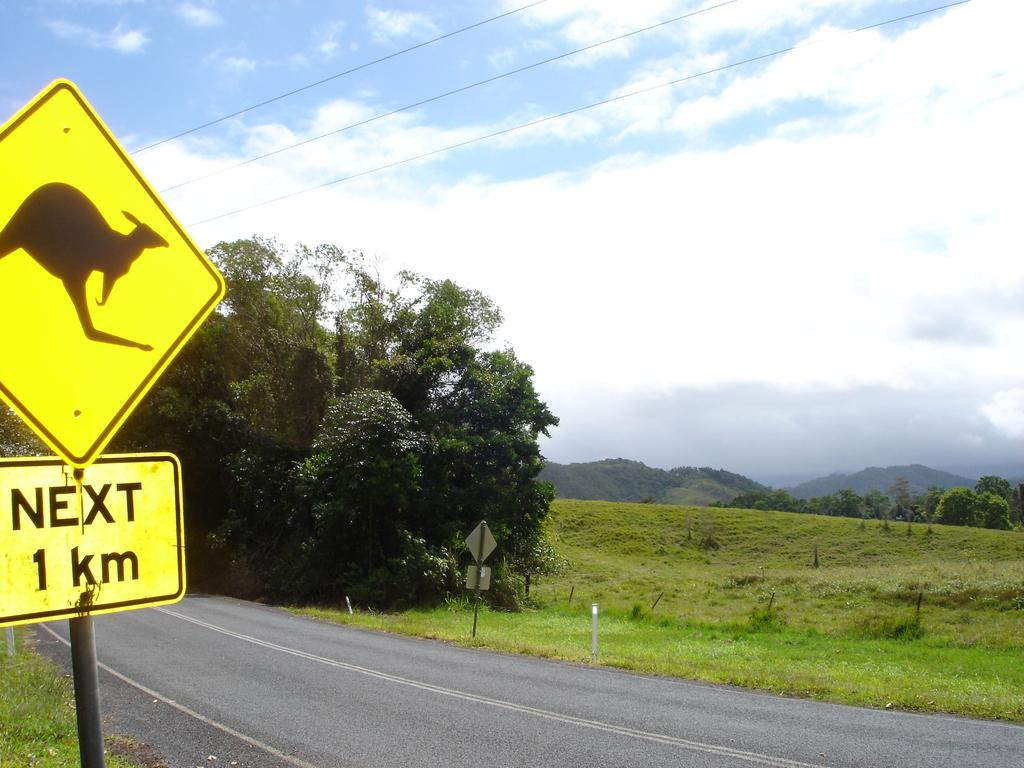<image>
Give a short and clear explanation of the subsequent image. A yellow road sign warns about kangaroos for the next 1 km. 